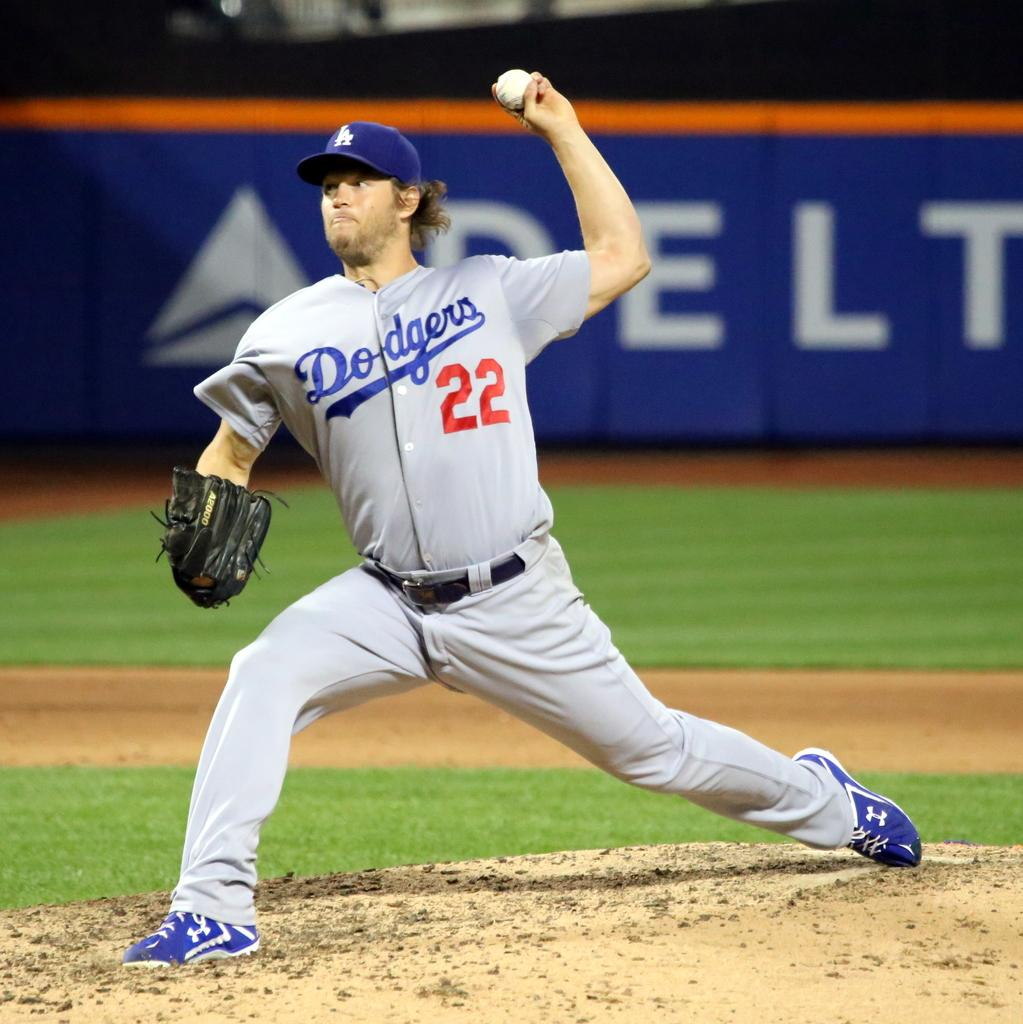<image>
Summarize the visual content of the image. Player number 22 for the Dodgers gets ready to throw the baseball. 